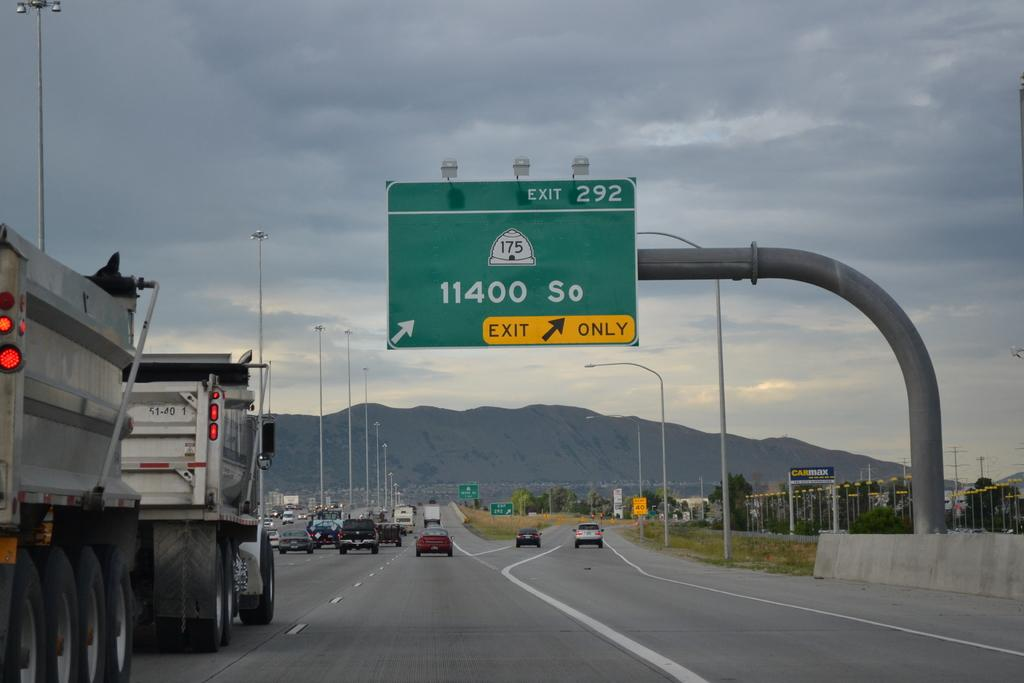<image>
Describe the image concisely. a 11400 So sign above the freeway in day 